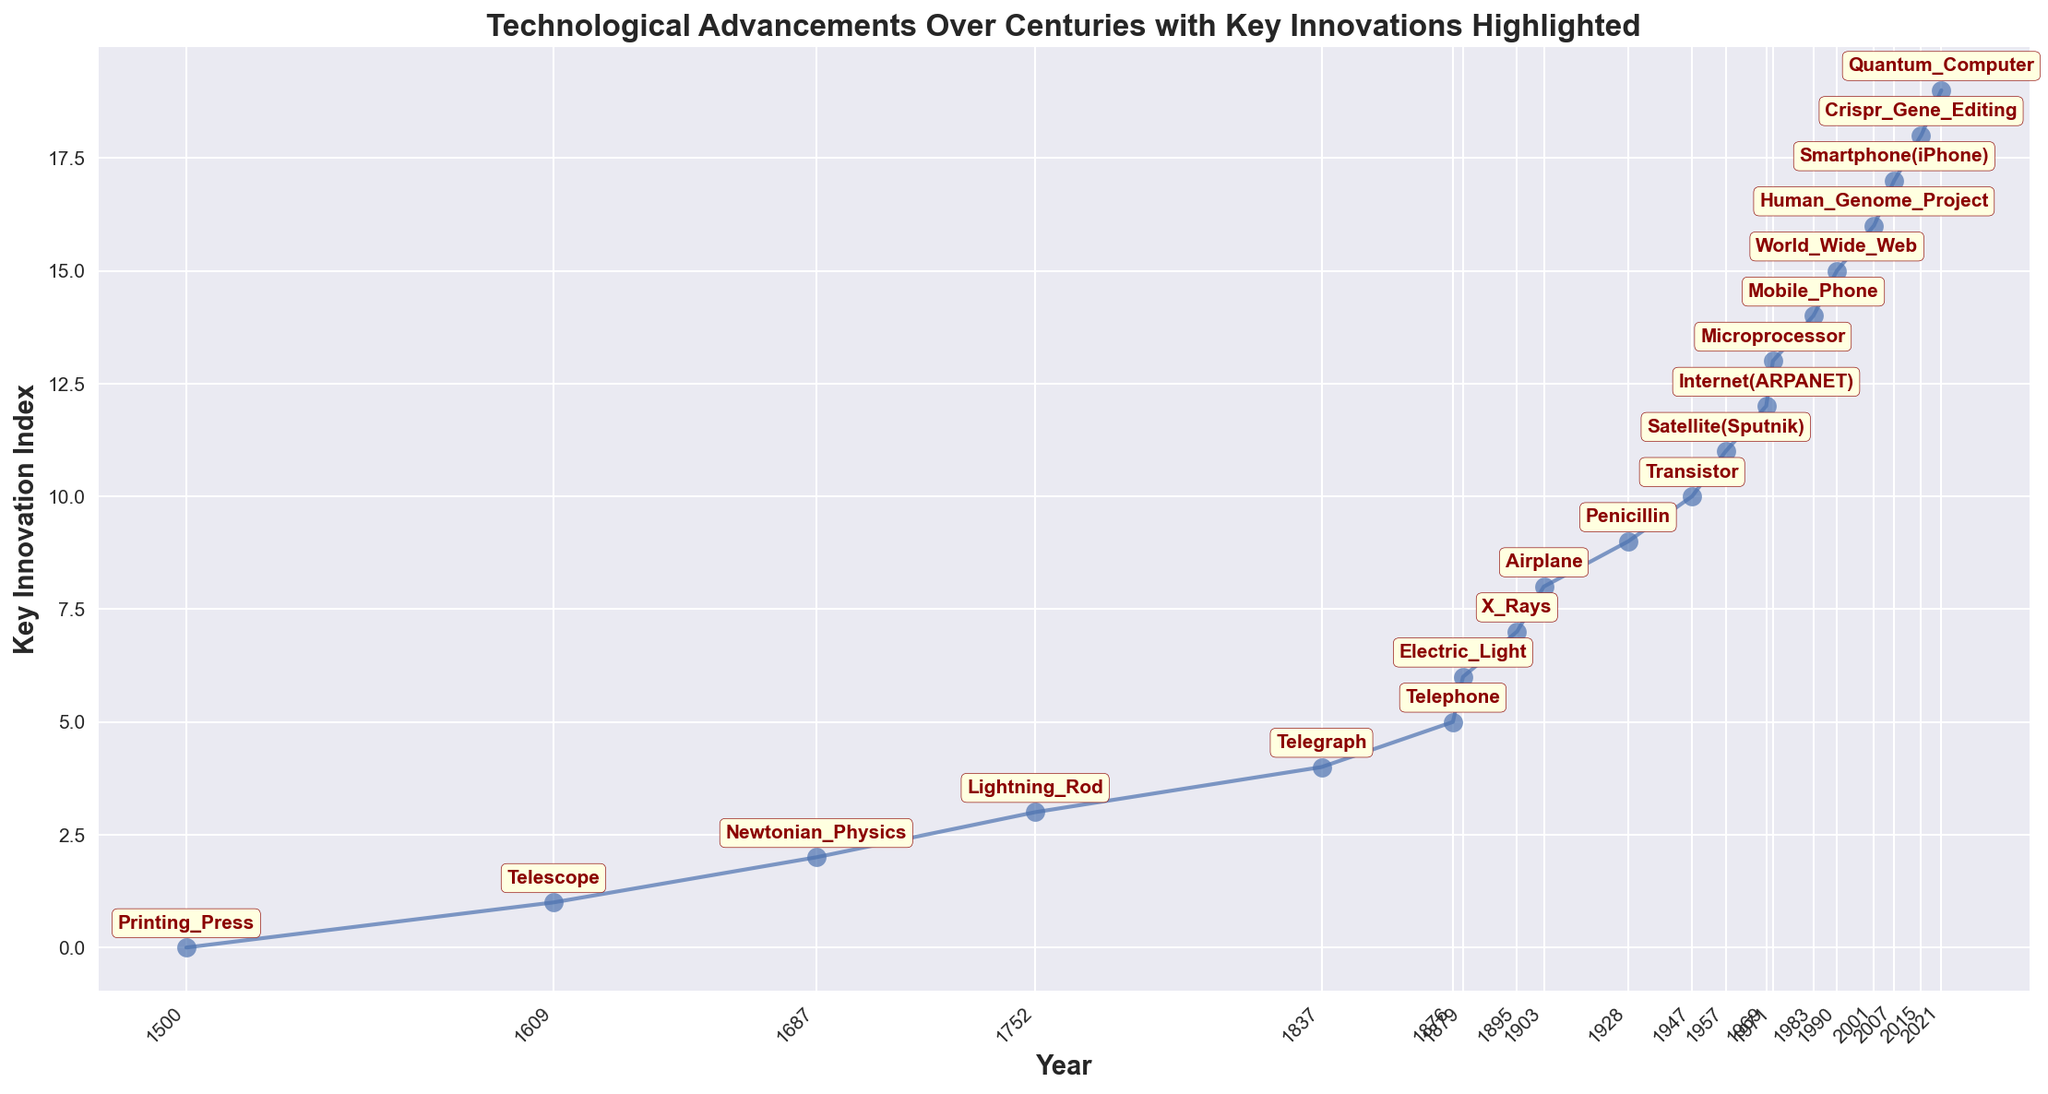How many years passed between the introduction of the Printing Press and the development of the Quantum Computer? The Printing Press was introduced in 1500 and the Quantum Computer in 2021. Calculating the difference between these years gives 2021 - 1500 = 521 years.
Answer: 521 Which innovation was introduced first, the Electric Light or the Airplane? Referring to the years on the line chart, Electric Light was introduced in 1879 and Airplane in 1903. Since 1879 is earlier than 1903, Electric Light was introduced first.
Answer: Electric Light What is the average time gap between each highlighted key innovation from 1500 to 2021? To calculate the average time gap, the total time span needs to be divided by the number of gaps. The total time span is 2021 - 1500 = 521 years. There are 20 key innovations, so there are 19 gaps. The average time gap is 521 / 19 ≈ 27.4 years.
Answer: 27.4 years How many key innovations were introduced in the 20th century? Key innovations in the 20th century fall between 1901 and 2000. The highlighted innovations within these years are: Airplane (1903), Penicillin (1928), Transistor (1947), Satellite (1957), Internet (1969), Microprocessor (1971), Mobile Phone (1983), and World Wide Web (1990). Count is 8.
Answer: 8 What was the key innovation immediately preceding the introduction of the World Wide Web? By looking at the sequence of the years, the innovation just before World Wide Web (1990) is the Mobile Phone (1983).
Answer: Mobile Phone Between which pair of successive key innovations was the longest time gap? To find the longest time gap, examine the intervals: 1500-1609 (109), 1609-1687 (78), 1687-1752 (65), etc. The largest gap is between 1500 (Printing Press) and 1609 (Telescope), which is 109 years.
Answer: Printing Press, Telescope Which innovation directly followed the development of Penicillin? Referring to the line chart, after Penicillin (1928), the next innovation is the Transistor (1947).
Answer: Transistor What were the two key innovations introduced just before and after the microprocessor? Before the Microprocessor (1971) was the Internet (1969), and after was the Mobile Phone (1983).
Answer: Internet, Mobile Phone What is the visual style used in the chart for annotating key innovations? The chart uses text annotations with dark red color and a bold font within a light yellow background box.
Answer: Dark red text, bold font, light yellow background Which innovation is annotated exactly at the middle of the timeline? Given the timeline from 1500 to 2021, the middle is approximately around 1752 (Lightning Rod), but mathematically the 10th innovation (about the midpoint in count and spread as indexed) is the Airplane (1903).
Answer: Airplane 